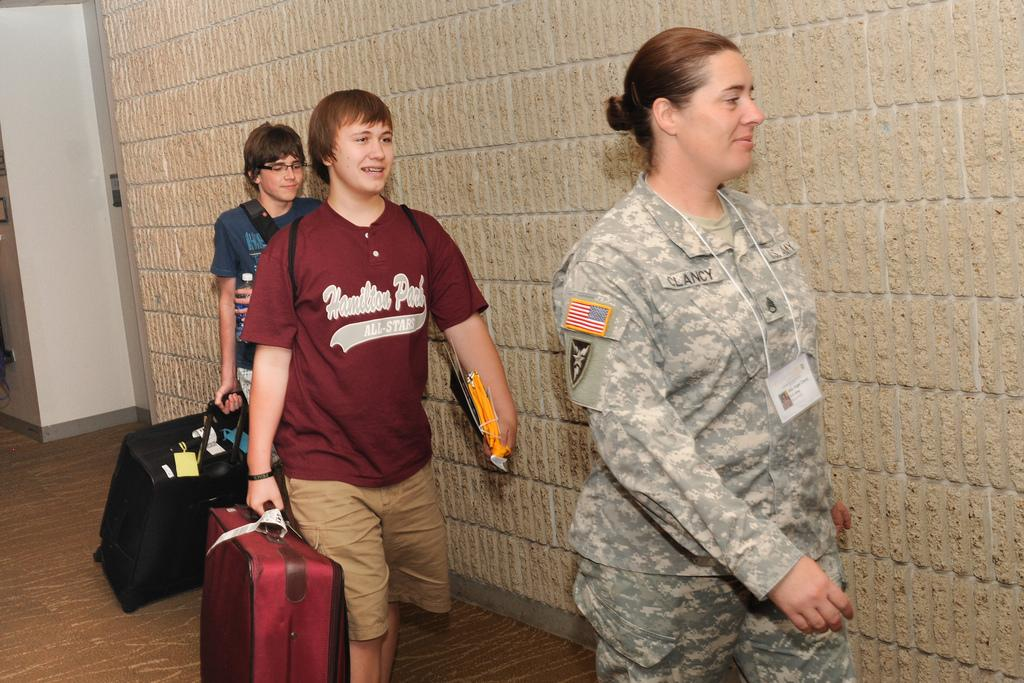How many people are in the image? There are three persons in the image. What are the persons doing in the image? The persons are walking. What are the persons carrying in the image? The persons are holding luggages and bags. What can be seen on the top and left side of the image? There is a wall on the top and left side of the image. How many cubs are visible in the image? There are no cubs present in the image. What type of beggar can be seen in the image? There is no beggar present in the image. 